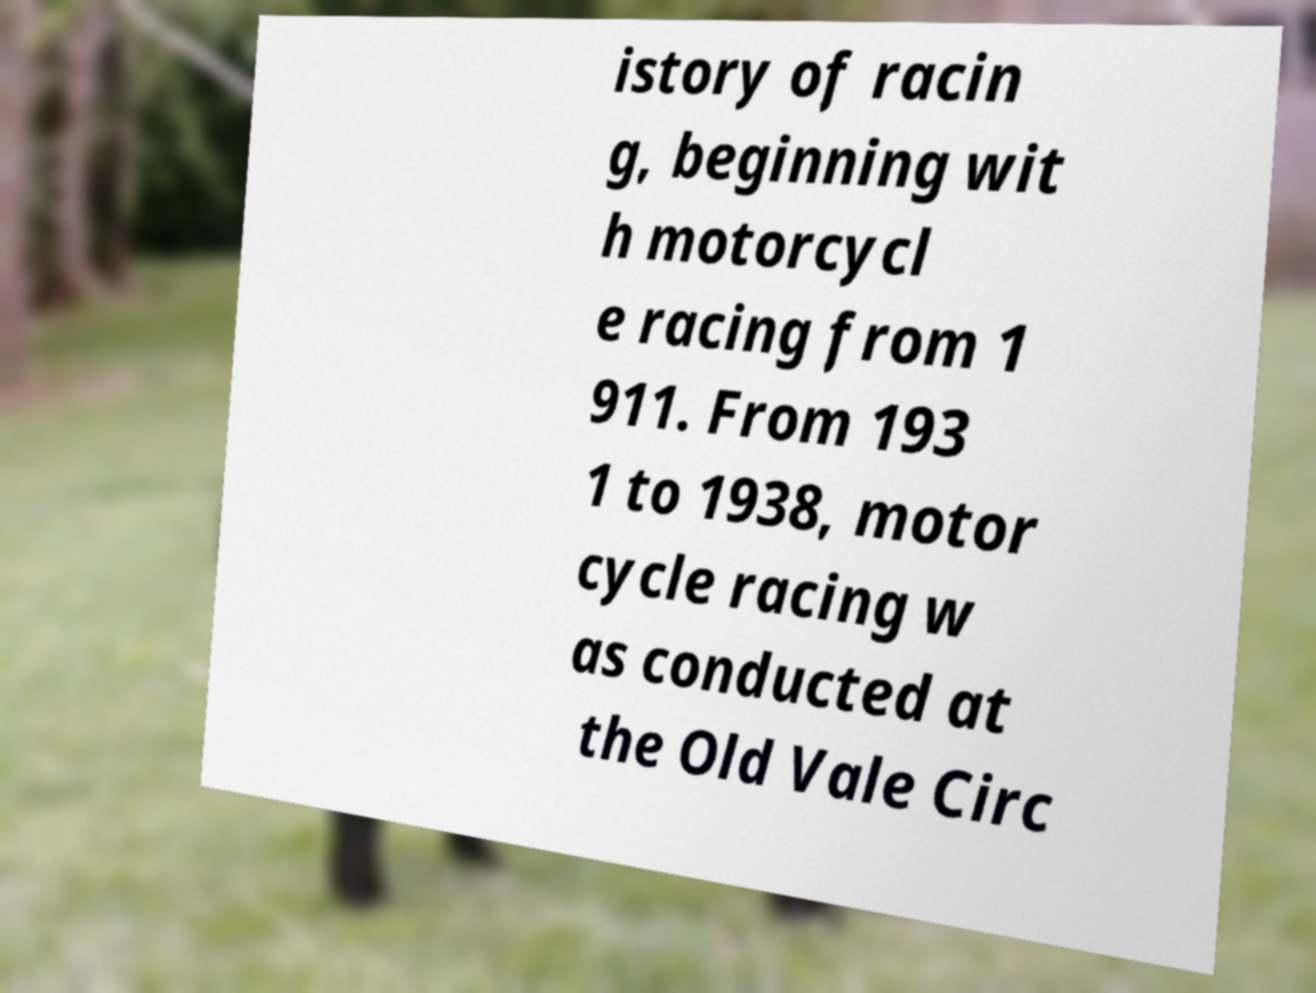Can you accurately transcribe the text from the provided image for me? istory of racin g, beginning wit h motorcycl e racing from 1 911. From 193 1 to 1938, motor cycle racing w as conducted at the Old Vale Circ 